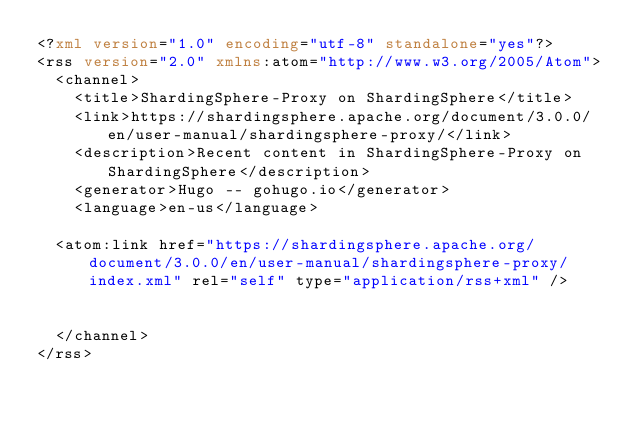<code> <loc_0><loc_0><loc_500><loc_500><_XML_><?xml version="1.0" encoding="utf-8" standalone="yes"?>
<rss version="2.0" xmlns:atom="http://www.w3.org/2005/Atom">
  <channel>
    <title>ShardingSphere-Proxy on ShardingSphere</title>
    <link>https://shardingsphere.apache.org/document/3.0.0/en/user-manual/shardingsphere-proxy/</link>
    <description>Recent content in ShardingSphere-Proxy on ShardingSphere</description>
    <generator>Hugo -- gohugo.io</generator>
    <language>en-us</language>
    
	<atom:link href="https://shardingsphere.apache.org/document/3.0.0/en/user-manual/shardingsphere-proxy/index.xml" rel="self" type="application/rss+xml" />
    
    
  </channel>
</rss></code> 